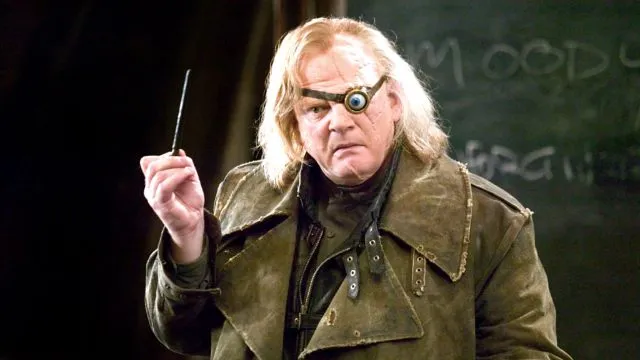Can you describe the character's attire and how it complements his role? The character, Alastor 'Mad-Eye' Moody, is dressed in a long, dark green coat that exudes a sense of mystery and authority, perfectly aligning with his role as a formidable Auror. The rugged and worn look of his coat suggests countless battles fought and a deep-seated resolve. His right eye is replaced with a magical prosthetic eye, known for its ability to see through almost anything, capturing the character's vigilant and ever-watchful nature. Holding a wand firmly, he seems ready for any challenge, embodying the intensity and readiness required for his dangerous and vigilant duties. 